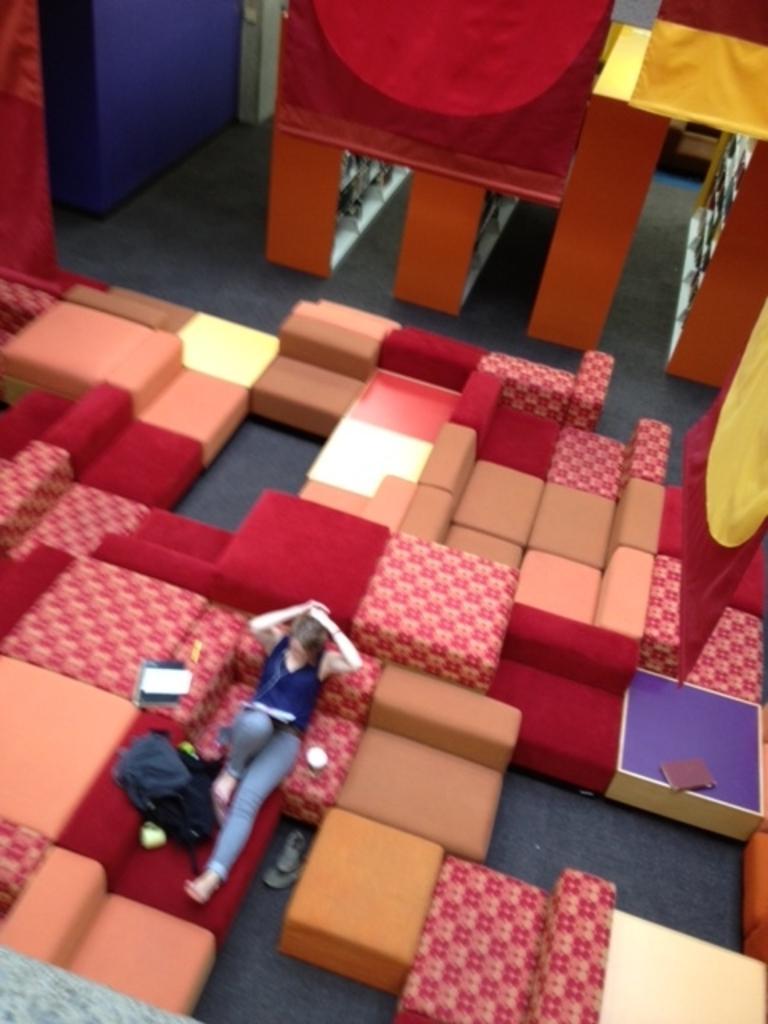Please provide a concise description of this image. In this image in the center there are some couches and some chairs, and also there is one person who is sitting and she is holding some papers. Beside her there are some bags and in the background there are some curtains, wall and some other objects. 